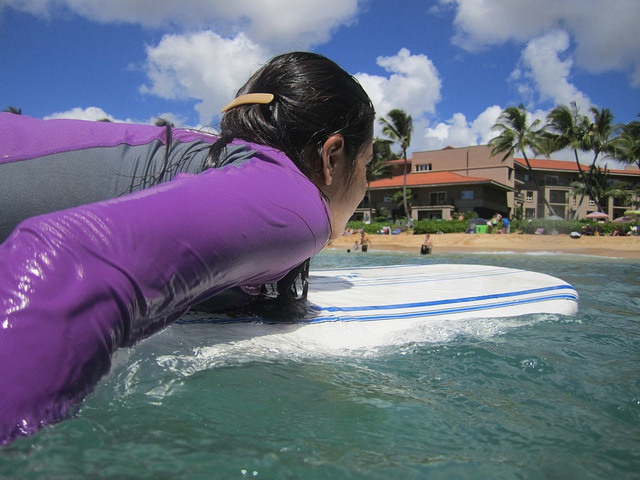Describe the objects in this image and their specific colors. I can see people in gray, purple, and black tones, surfboard in gray, lightgray, darkgray, and lightblue tones, people in gray, tan, and black tones, people in gray and blue tones, and people in gray and tan tones in this image. 